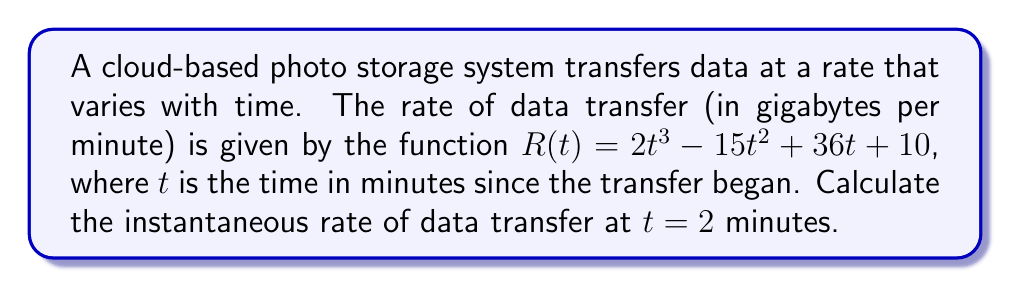Can you answer this question? To find the instantaneous rate of data transfer at $t = 2$ minutes, we need to calculate the derivative of the given function $R(t)$ and then evaluate it at $t = 2$.

1. Given function: $R(t) = 2t^3 - 15t^2 + 36t + 10$

2. Calculate the derivative $R'(t)$:
   $$\begin{align}
   R'(t) &= \frac{d}{dt}(2t^3 - 15t^2 + 36t + 10) \\
   &= 6t^2 - 30t + 36
   \end{align}$$

3. Evaluate $R'(t)$ at $t = 2$:
   $$\begin{align}
   R'(2) &= 6(2)^2 - 30(2) + 36 \\
   &= 6(4) - 60 + 36 \\
   &= 24 - 60 + 36 \\
   &= 0
   \end{align}$$

The instantaneous rate of data transfer at $t = 2$ minutes is 0 GB/min. This means that at exactly 2 minutes into the transfer, the rate of change of data transfer is momentarily zero, which could indicate a turning point in the transfer rate function.
Answer: 0 GB/min 